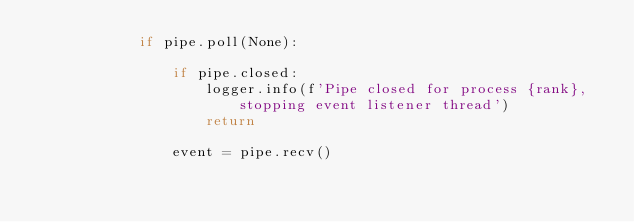Convert code to text. <code><loc_0><loc_0><loc_500><loc_500><_Python_>            if pipe.poll(None):

                if pipe.closed:
                    logger.info(f'Pipe closed for process {rank}, stopping event listener thread')
                    return

                event = pipe.recv()</code> 